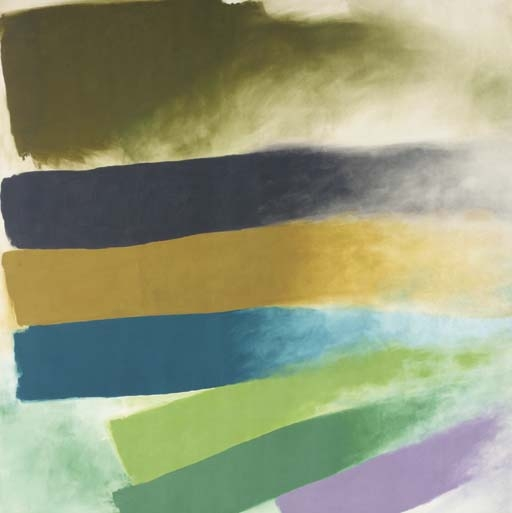How might this painting fit into a modern living space? This piece could serve as a striking focal point in a modern living space. Its large, bold bands of color can complement minimalist decor, adding a splash of color without overwhelming the surroundings. The abstract nature allows it to blend with various styles, especially in spaces that favor contemporary or mid-century modern aesthetics. Placed in a room with neutral tones, this artwork could really stand out, adding both elegance and a vibrant energy. 